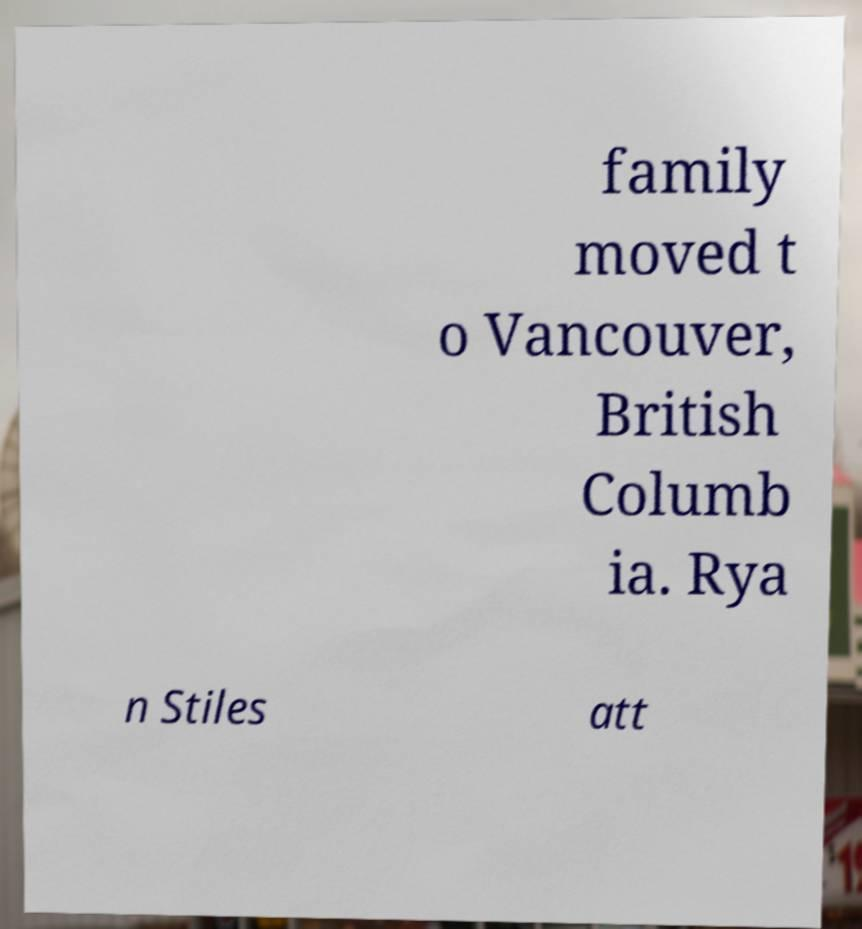I need the written content from this picture converted into text. Can you do that? family moved t o Vancouver, British Columb ia. Rya n Stiles att 